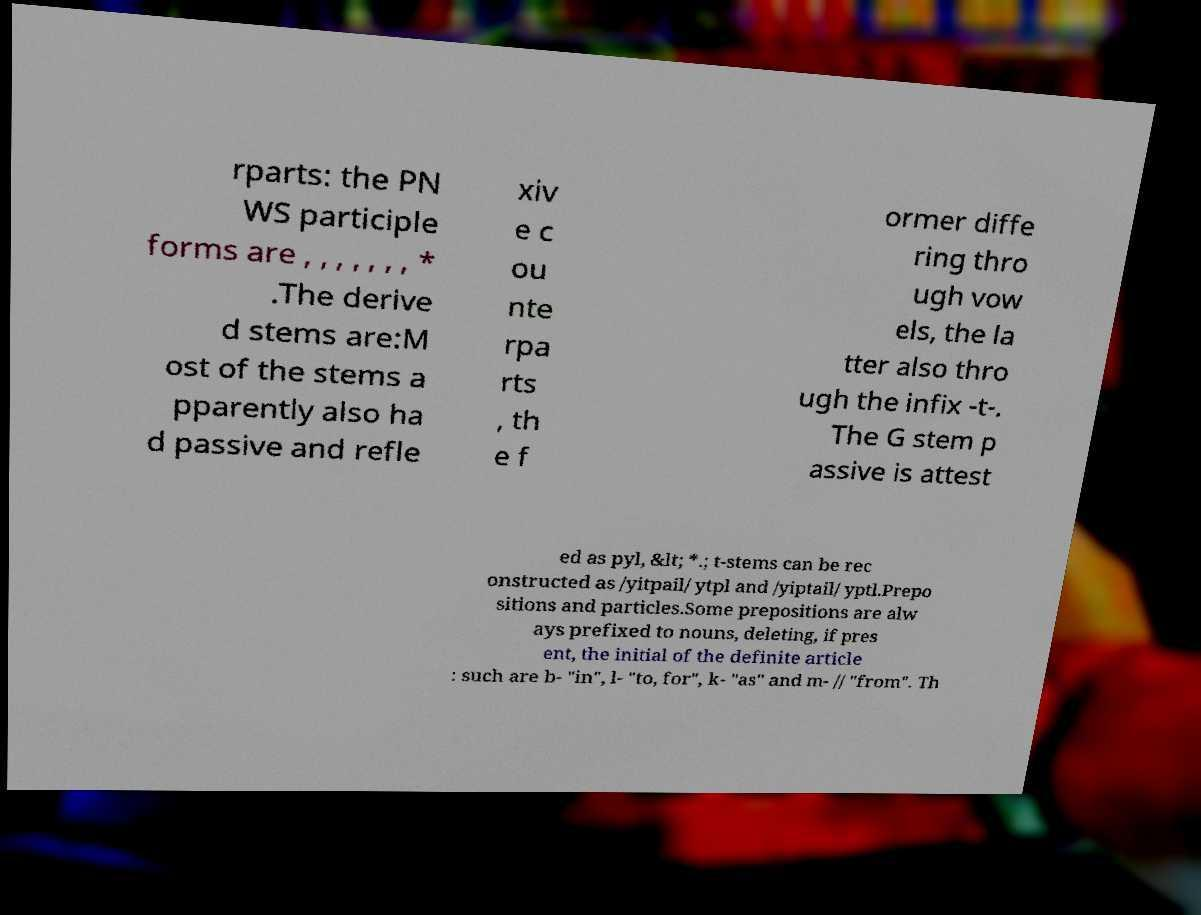I need the written content from this picture converted into text. Can you do that? rparts: the PN WS participle forms are , , , , , , , * .The derive d stems are:M ost of the stems a pparently also ha d passive and refle xiv e c ou nte rpa rts , th e f ormer diffe ring thro ugh vow els, the la tter also thro ugh the infix -t-. The G stem p assive is attest ed as pyl, &lt; *.; t-stems can be rec onstructed as /yitpail/ ytpl and /yiptail/ yptl.Prepo sitions and particles.Some prepositions are alw ays prefixed to nouns, deleting, if pres ent, the initial of the definite article : such are b- "in", l- "to, for", k- "as" and m- // "from". Th 